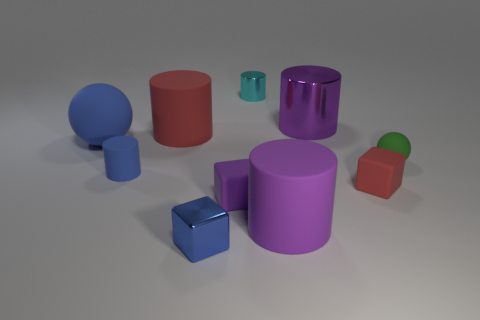Are there any shiny things that have the same color as the tiny shiny cylinder?
Your answer should be very brief. No. There is a purple object that is the same size as the cyan shiny cylinder; what is its shape?
Offer a very short reply. Cube. There is a rubber object that is behind the big blue thing; is its color the same as the large metallic cylinder?
Make the answer very short. No. What number of things are red matte objects to the right of the cyan object or tiny green cylinders?
Offer a very short reply. 1. Is the number of large balls on the right side of the cyan cylinder greater than the number of small blue matte cylinders behind the big blue rubber ball?
Provide a succinct answer. No. Do the small cyan cylinder and the tiny purple thing have the same material?
Your response must be concise. No. What shape is the big matte object that is both on the left side of the tiny metal cylinder and on the right side of the small blue rubber thing?
Provide a short and direct response. Cylinder. There is a small green object that is made of the same material as the big ball; what is its shape?
Ensure brevity in your answer.  Sphere. Are any blocks visible?
Ensure brevity in your answer.  Yes. There is a red rubber object on the left side of the blue shiny block; are there any metallic things in front of it?
Your response must be concise. Yes. 